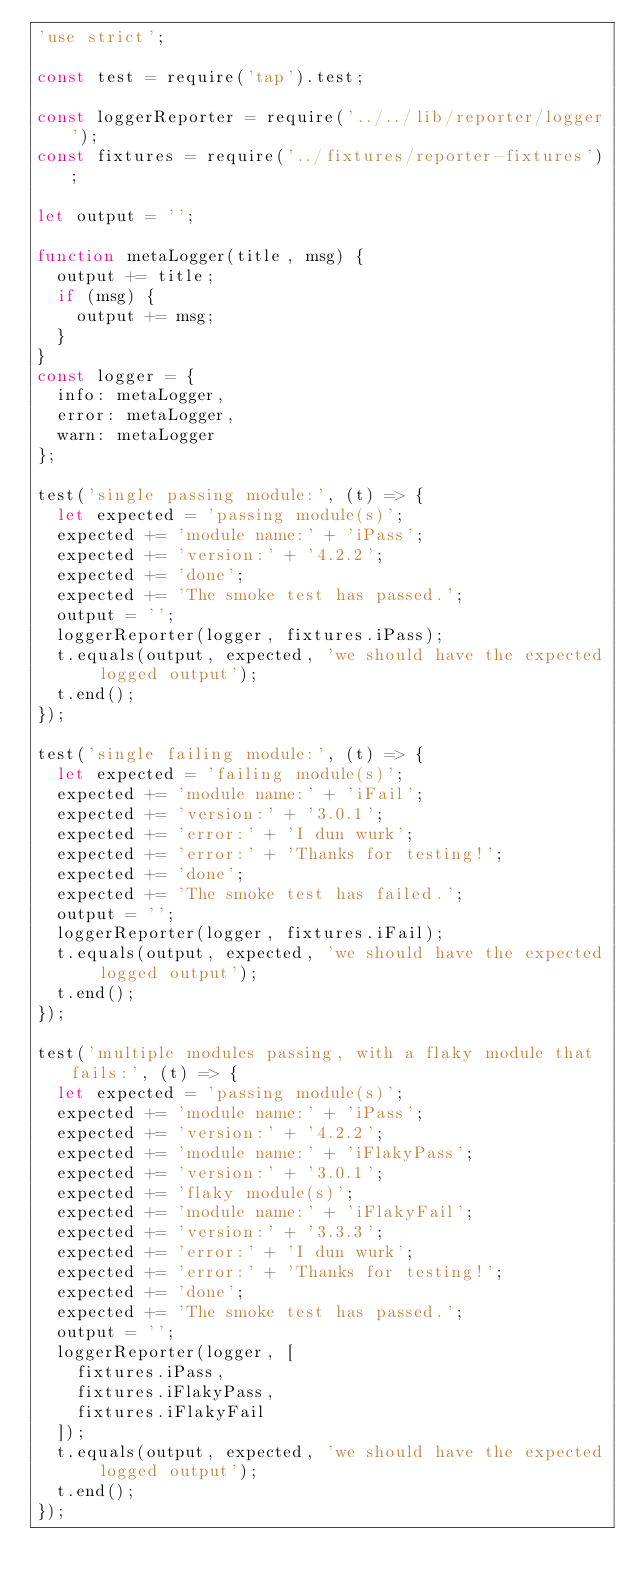<code> <loc_0><loc_0><loc_500><loc_500><_JavaScript_>'use strict';

const test = require('tap').test;

const loggerReporter = require('../../lib/reporter/logger');
const fixtures = require('../fixtures/reporter-fixtures');

let output = '';

function metaLogger(title, msg) {
  output += title;
  if (msg) {
    output += msg;
  }
}
const logger = {
  info: metaLogger,
  error: metaLogger,
  warn: metaLogger
};

test('single passing module:', (t) => {
  let expected = 'passing module(s)';
  expected += 'module name:' + 'iPass';
  expected += 'version:' + '4.2.2';
  expected += 'done';
  expected += 'The smoke test has passed.';
  output = '';
  loggerReporter(logger, fixtures.iPass);
  t.equals(output, expected, 'we should have the expected logged output');
  t.end();
});

test('single failing module:', (t) => {
  let expected = 'failing module(s)';
  expected += 'module name:' + 'iFail';
  expected += 'version:' + '3.0.1';
  expected += 'error:' + 'I dun wurk';
  expected += 'error:' + 'Thanks for testing!';
  expected += 'done';
  expected += 'The smoke test has failed.';
  output = '';
  loggerReporter(logger, fixtures.iFail);
  t.equals(output, expected, 'we should have the expected logged output');
  t.end();
});

test('multiple modules passing, with a flaky module that fails:', (t) => {
  let expected = 'passing module(s)';
  expected += 'module name:' + 'iPass';
  expected += 'version:' + '4.2.2';
  expected += 'module name:' + 'iFlakyPass';
  expected += 'version:' + '3.0.1';
  expected += 'flaky module(s)';
  expected += 'module name:' + 'iFlakyFail';
  expected += 'version:' + '3.3.3';
  expected += 'error:' + 'I dun wurk';
  expected += 'error:' + 'Thanks for testing!';
  expected += 'done';
  expected += 'The smoke test has passed.';
  output = '';
  loggerReporter(logger, [
    fixtures.iPass,
    fixtures.iFlakyPass,
    fixtures.iFlakyFail
  ]);
  t.equals(output, expected, 'we should have the expected logged output');
  t.end();
});
</code> 